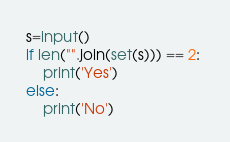Convert code to text. <code><loc_0><loc_0><loc_500><loc_500><_Python_>s=input()
if len("".join(set(s))) == 2: 
    print('Yes') 
else: 
    print('No')</code> 